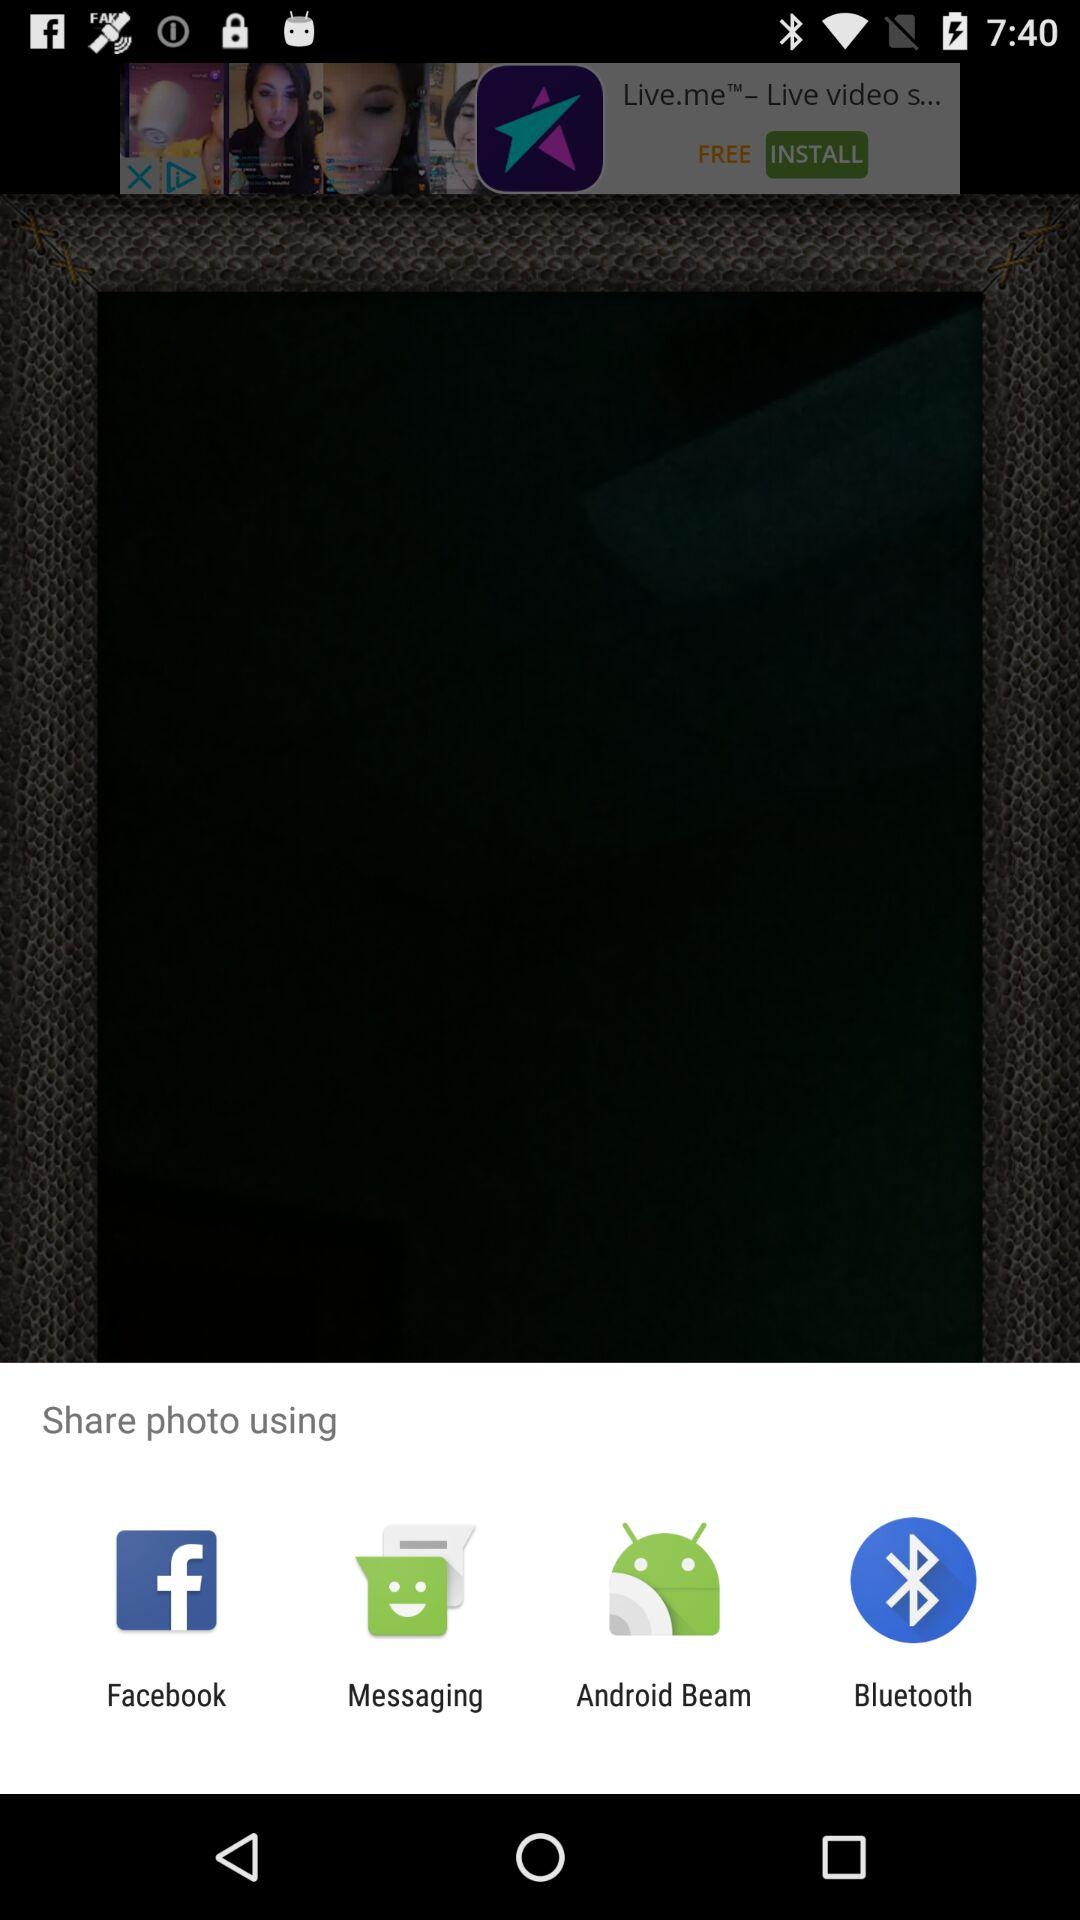What are the different mediums to share? The different mediums to share are "Facebook", "Messaging", "Android Beam" and "Bluetooth". 